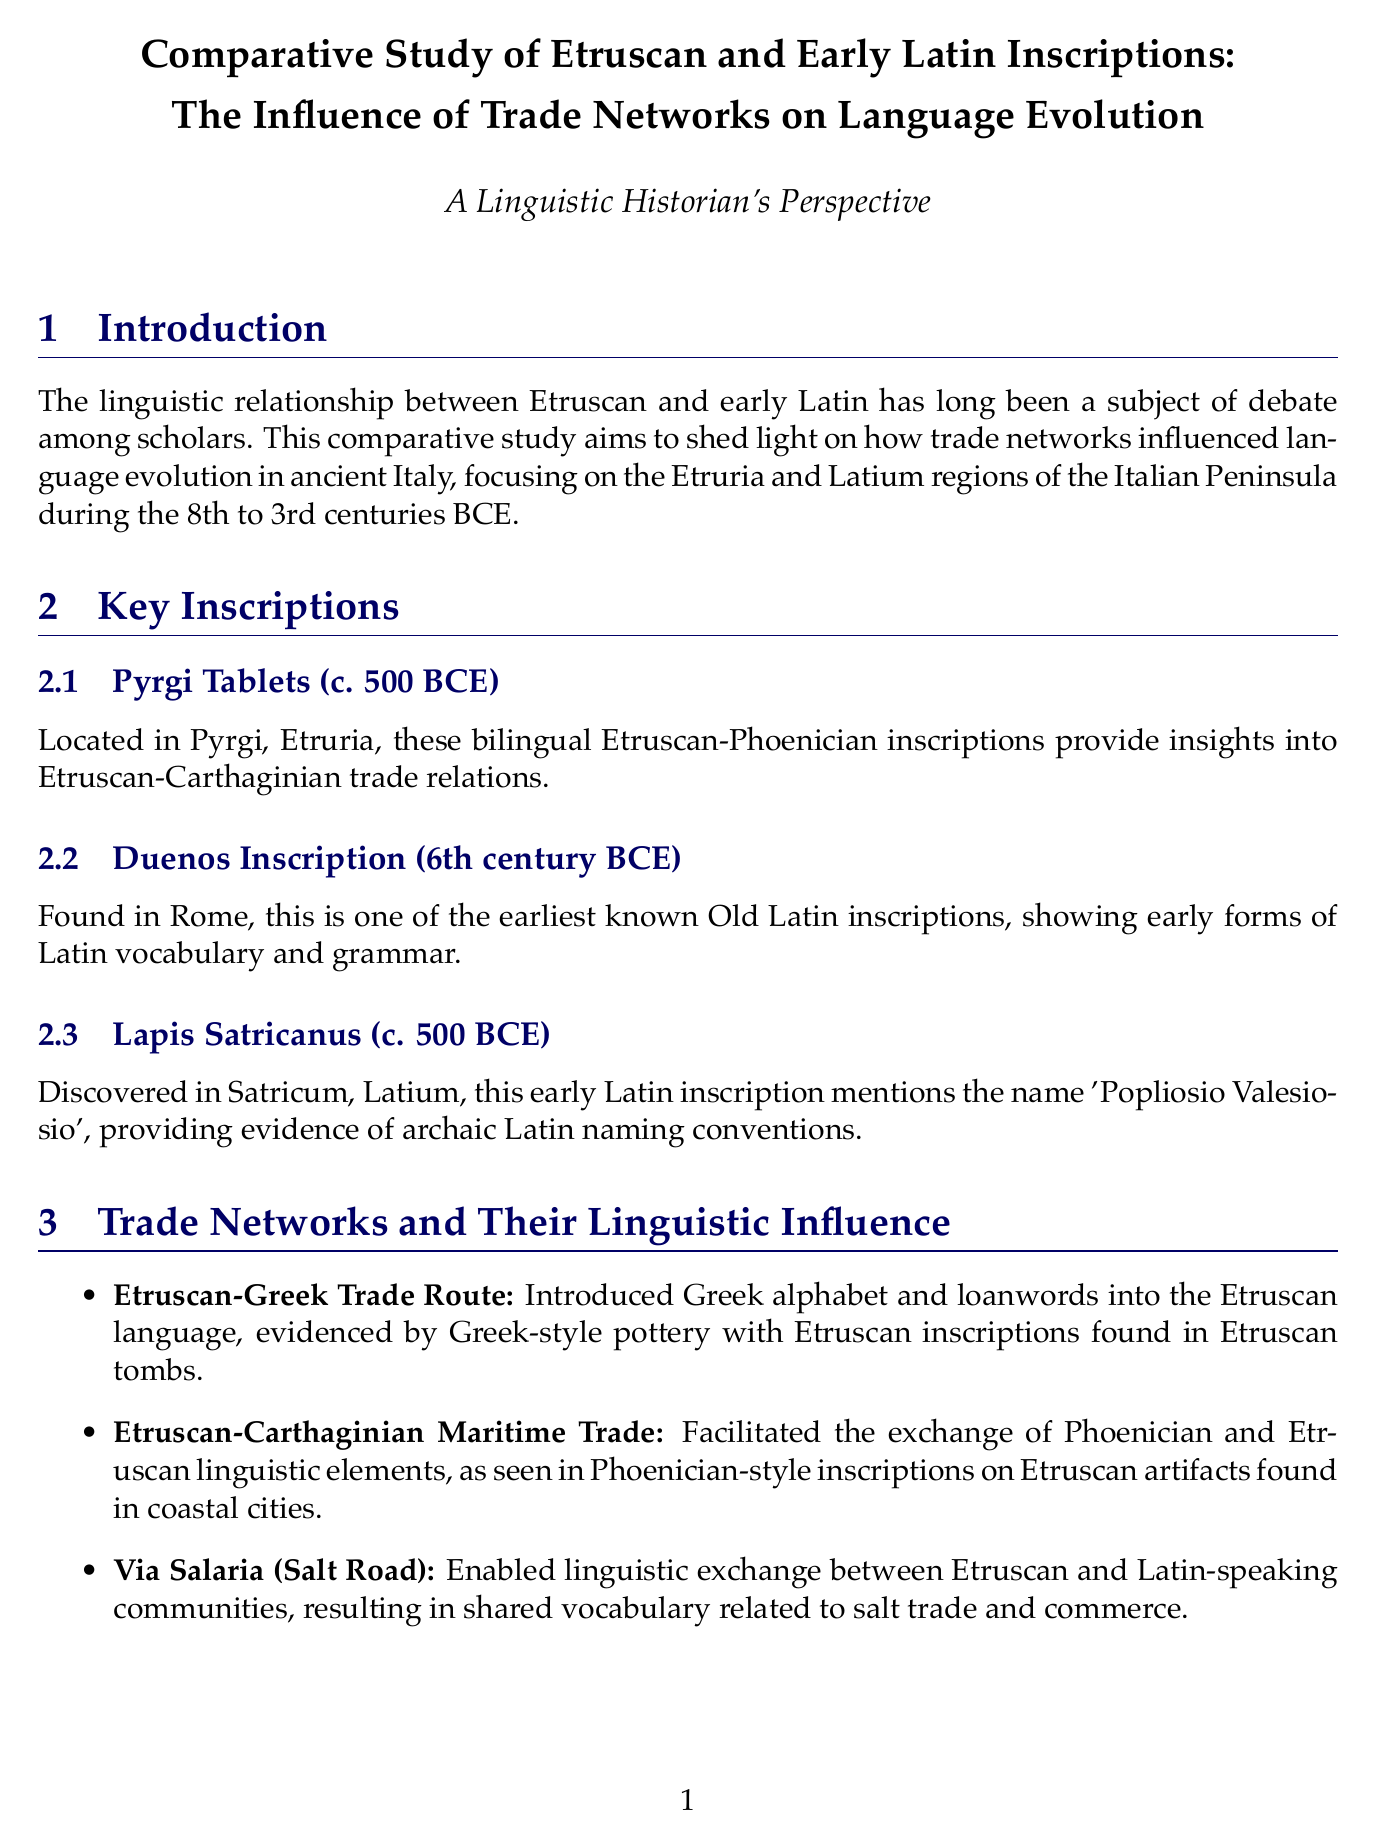What is the timeframe of the study? The timeframe of the study is specified as the period under investigation, which is from the 8th to the 3rd centuries BCE.
Answer: 8th to 3rd centuries BCE What are the Pyrgi Tablets? The Pyrgi Tablets are mentioned as entering into the key inscriptions, indicating their significance and providing insights into Etruscan-Carthaginian trade relations.
Answer: Bilingual Etruscan-Phoenician inscription What does the Duenos Inscription show? The Duenos Inscription is discussed as demonstrating early forms of Latin vocabulary and grammar, making it significant in the study.
Answer: Early forms of Latin vocabulary and grammar Who proposed the Etruscan-Latin Creolization theory? The document specifies the proponent of the theory on Etruscan-Latin creolization, leading to insights on language development due to trade.
Answer: Dr. Elena Bianchi What influence did the Etruscan-Carthaginian Maritime Trade have? This section indicates specific linguistic influences related to maritime trade, particularly regarding Phoenician interactions.
Answer: Exchange of Phoenician and Etruscan linguistic elements What is one key difference noted in the syntax analysis? The syntax analysis mentions the examination of similarities and differences in inscriptions, highlighting comparisons in word order.
Answer: Word order patterns How many key inscriptions are highlighted in the study? The document lists the key inscriptions under a specific section, revealing a count that reflects the scope of the examples presented.
Answer: Three What is the geographical focus of the study? The geographical focus is defined in the introduction section, noting the specific regions that are central to the research.
Answer: Etruria and Latium regions 